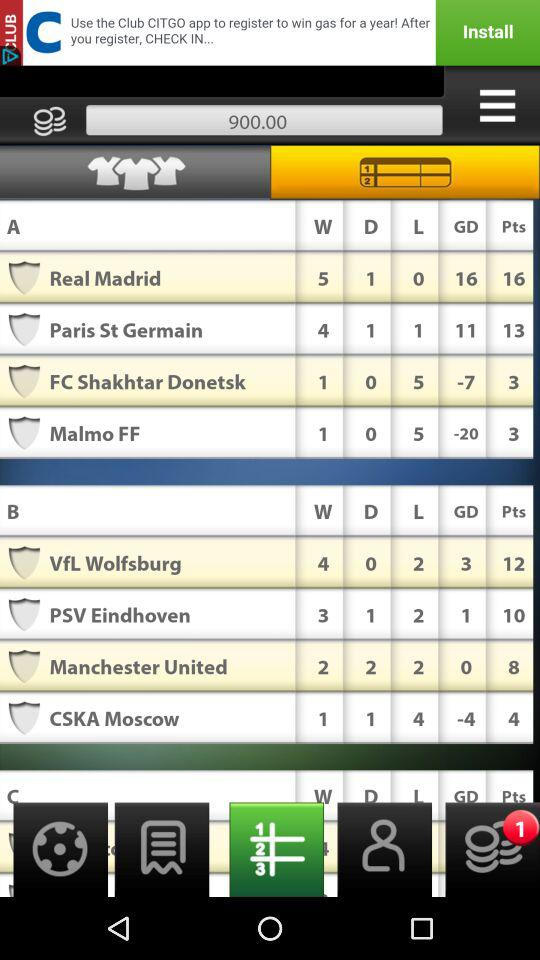How many goals have Real Madrid scored?
Answer the question using a single word or phrase. 16 